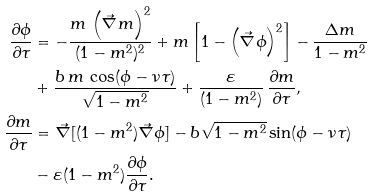Convert formula to latex. <formula><loc_0><loc_0><loc_500><loc_500>\frac { \partial \phi } { \partial \tau } & = - \frac { m \, \left ( \vec { \nabla } m \right ) ^ { 2 } } { ( 1 - m ^ { 2 } ) ^ { 2 } } + m \left [ 1 - \left ( \vec { \nabla } \phi \right ) ^ { 2 } \right ] - \frac { \Delta m } { 1 - m ^ { 2 } } \\ & + \frac { b \, m \, \cos ( \phi - \nu \tau ) } { \sqrt { 1 - m ^ { 2 } } } + \frac { \varepsilon } { ( 1 - m ^ { 2 } ) } \, \frac { \partial m } { \partial \tau } , \\ \frac { \partial m } { \partial \tau } & = \vec { \nabla } [ ( 1 - m ^ { 2 } ) \vec { \nabla } \phi ] - b \sqrt { 1 - m ^ { 2 } } \sin ( \phi - \nu \tau ) \\ & - \varepsilon ( 1 - m ^ { 2 } ) \frac { \partial \phi } { \partial \tau } .</formula> 